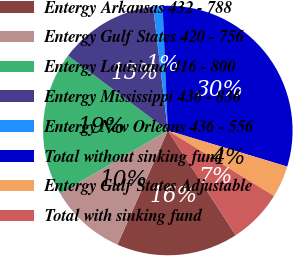Convert chart. <chart><loc_0><loc_0><loc_500><loc_500><pie_chart><fcel>Entergy Arkansas 432 - 788<fcel>Entergy Gulf States 420 - 756<fcel>Entergy Louisiana 416 - 800<fcel>Entergy Mississippi 436 - 836<fcel>Entergy New Orleans 436 - 556<fcel>Total without sinking fund<fcel>Entergy Gulf States Adjustable<fcel>Total with sinking fund<nl><fcel>15.77%<fcel>9.95%<fcel>18.68%<fcel>12.86%<fcel>1.22%<fcel>30.32%<fcel>4.13%<fcel>7.04%<nl></chart> 